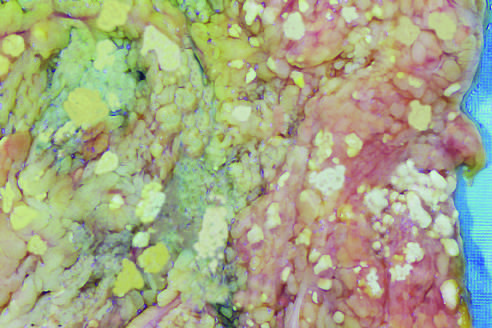what do the areas of white chalky deposits represent?
Answer the question using a single word or phrase. Foci of fat necrosis 